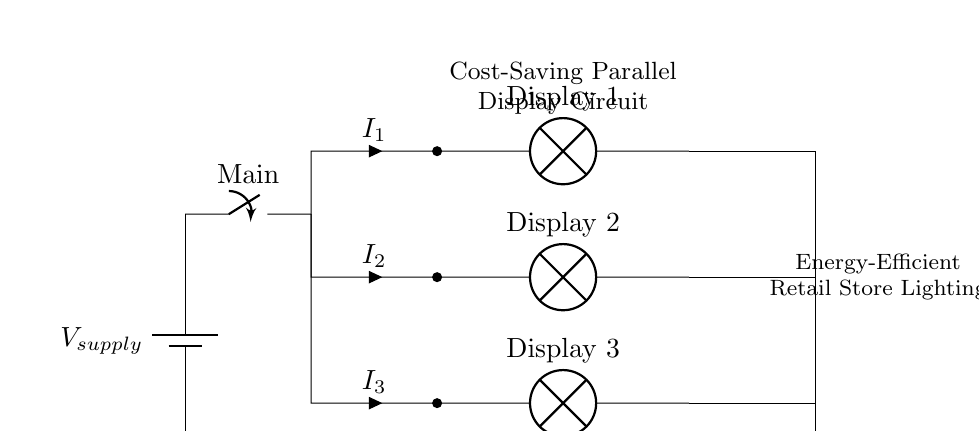What type of circuit is shown in the diagram? The circuit is a parallel circuit, as multiple components are connected across the same voltage source, allowing each display to operate independently.
Answer: Parallel How many displays are powered in this circuit? There are three displays connected in parallel, each receiving power from the same voltage source.
Answer: Three What is the role of the main switch in the circuit? The main switch controls the flow of electricity in the entire circuit, allowing or preventing power from reaching all connected displays at once.
Answer: Control If one display fails, what happens to the others? Since the displays are connected in parallel, if one fails, the others continue to receive power and operate normally, maintaining functionality.
Answer: Remain operational What is the total current supplied by the source? The total current supplied by the source is the sum of the currents through each parallel branch, represented as I1, I2, and I3.
Answer: Sum of I1, I2, I3 Which component indicates the load in this circuit? The lamps labeled "Display 1," "Display 2," and "Display 3" indicate the loads in the circuit, converting electrical energy into light.
Answer: Lamps What advantage does a parallel circuit provide for retail display lighting? A parallel circuit allows for independent operation of displays, enhancing reliability, as each display can function without affecting the others.
Answer: Reliability 